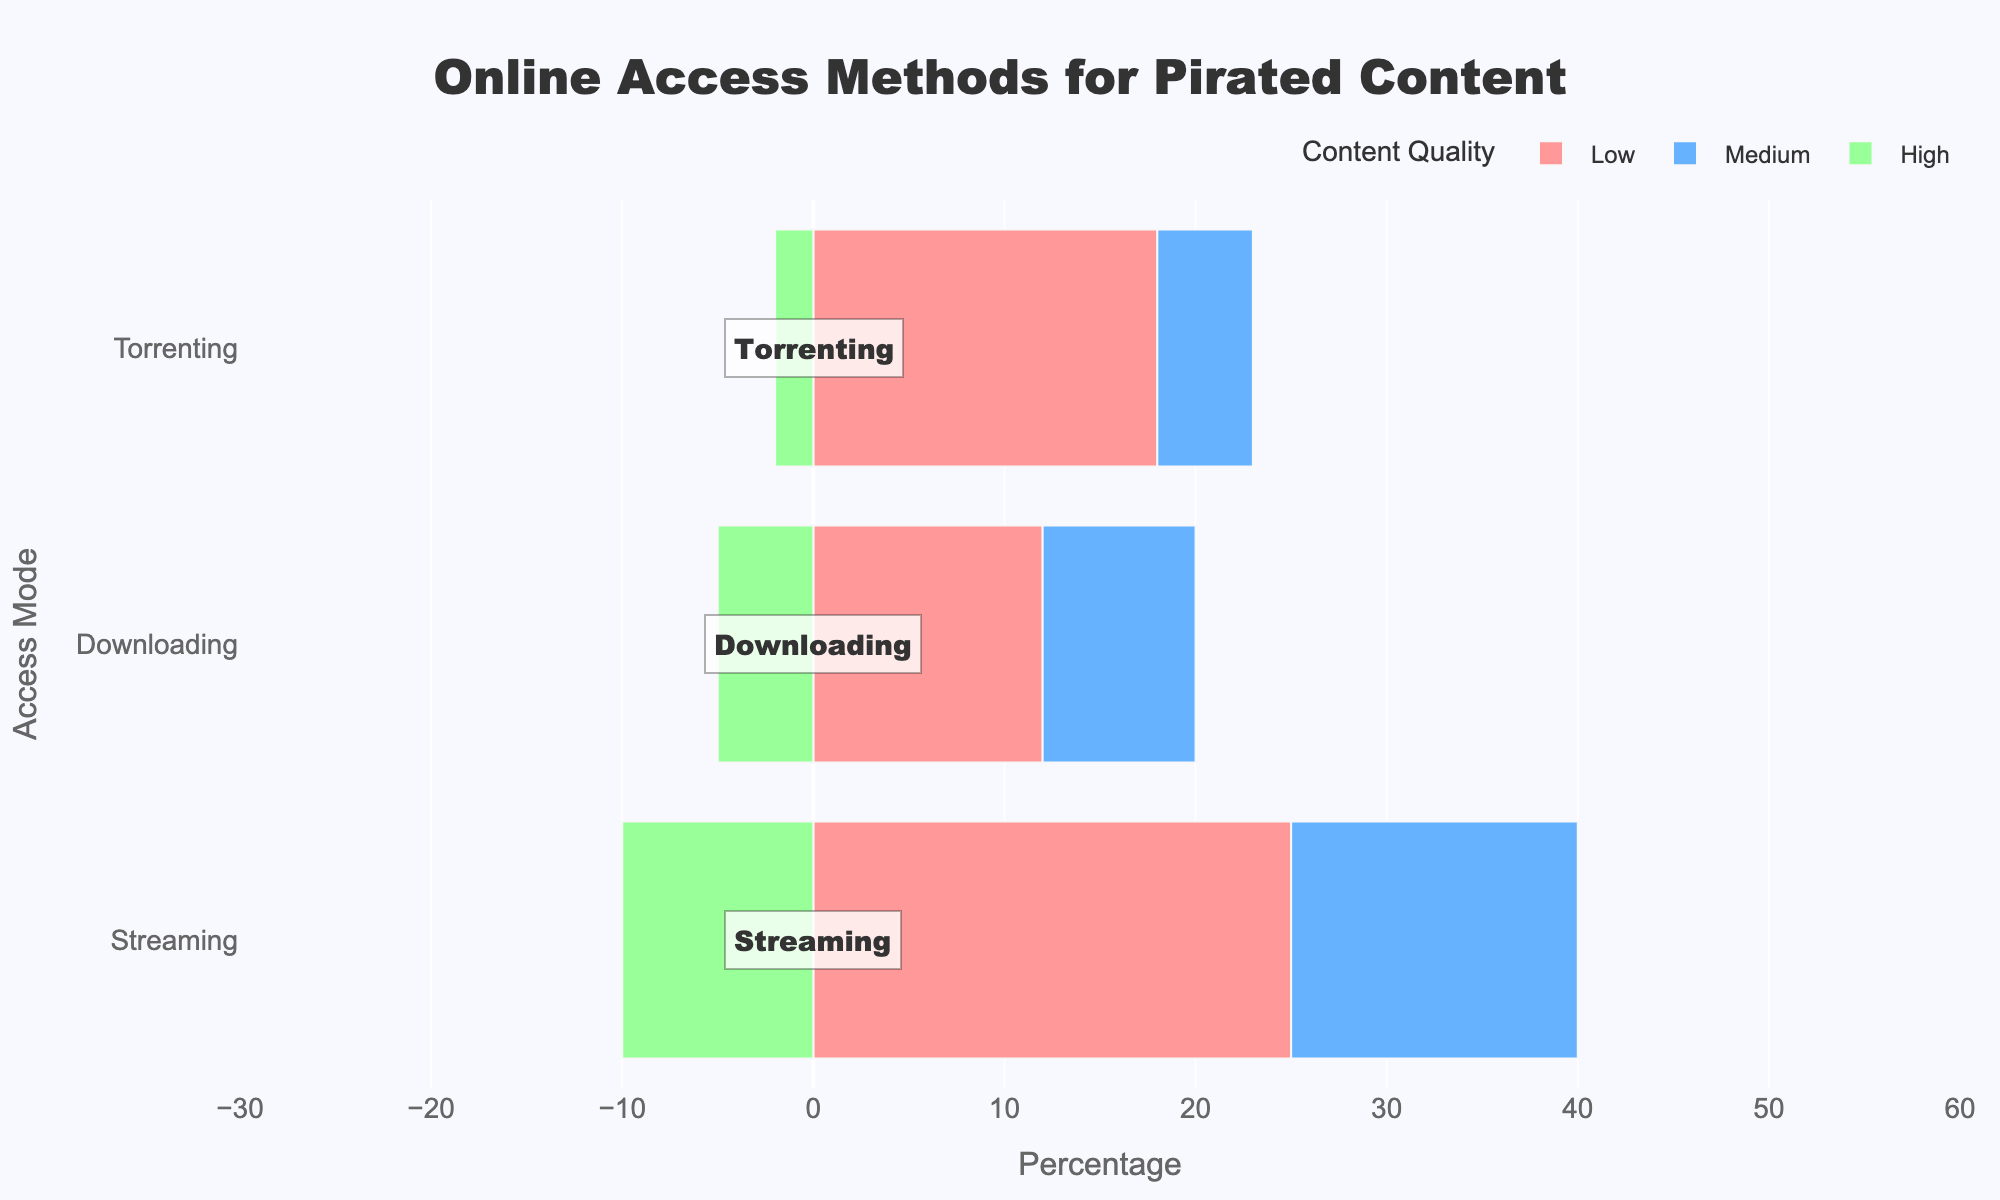Which access mode has the highest percentage for low-quality pirated content? Look at the bar lengths for low-quality content across different access modes. Streaming has the longest bar for low-quality content.
Answer: Streaming What is the combined percentage of medium and high-quality torrenting? Add the percentages for medium and high-quality in the torrenting mode. Medium is 5% and high is 2%, so 5 + 2 = 7%.
Answer: 7% Which access mode has the smallest percentage for high-quality content? Compare the negative bar lengths for high-quality content across all access modes. Torrenting has the smallest negative bar.
Answer: Torrenting Which quality type has the highest percentage in downloading? Compare the bar lengths for different quality types within downloading mode. Low quality has the longest bar.
Answer: Low Compare the combined percentage of high-quality content across all access modes. Which access mode contributes the least? Sum the negative percentages for high quality in each mode separately. Streaming: -10%, Downloading: -5%, Torrenting: -2%. Torrenting has the smallest sum.
Answer: Torrenting How much more popular is streaming for low-quality content compared to downloading in the same category? Subtract the percentage of low-quality downloading from low-quality streaming. Streaming: 25%, Downloading: 12%, so 25 - 12 = 13%.
Answer: 13% Which access mode has the closest percentage values for medium and high-quality contents? Look at the bars for medium and high quality in each access mode. Torrenting has medium (5%) and high (2%), with a difference of 3%, which is the smallest difference compared to other modes.
Answer: Torrenting What is the average percentage of downloading content across all quality types? Add the percentages for downloading across all quality types and divide by the number of types. (12 + 8 + 5)/3 = 25/3 ≈ 8.33%.
Answer: 8.33% What is the difference between the largest and smallest percentages within the same quality type across all access modes? Identify the largest and smallest percentages within each quality type. Low: 25 (Streaming) - 12 (Downloading) = 13, Medium: 15 (Streaming) - 5 (Torrenting) = 10, High: 10 (Streaming) - 2 (Torrenting) = 8. The biggest difference is in low quality: 13.
Answer: 13 